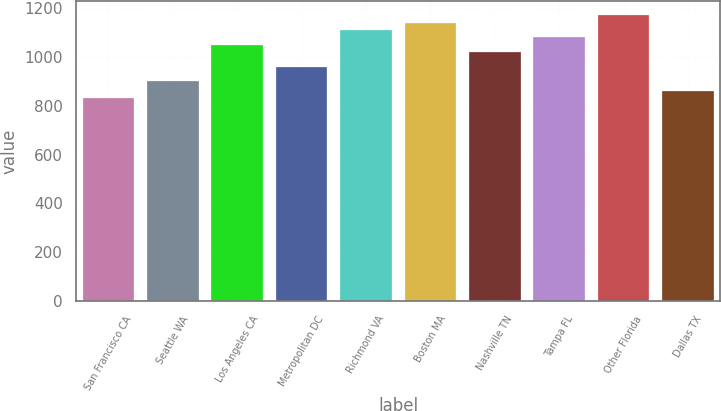<chart> <loc_0><loc_0><loc_500><loc_500><bar_chart><fcel>San Francisco CA<fcel>Seattle WA<fcel>Los Angeles CA<fcel>Metropolitan DC<fcel>Richmond VA<fcel>Boston MA<fcel>Nashville TN<fcel>Tampa FL<fcel>Other Florida<fcel>Dallas TX<nl><fcel>830<fcel>900<fcel>1050<fcel>960<fcel>1110<fcel>1140<fcel>1020<fcel>1080<fcel>1170<fcel>862<nl></chart> 